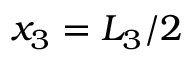<formula> <loc_0><loc_0><loc_500><loc_500>x _ { 3 } = L _ { 3 } / 2</formula> 